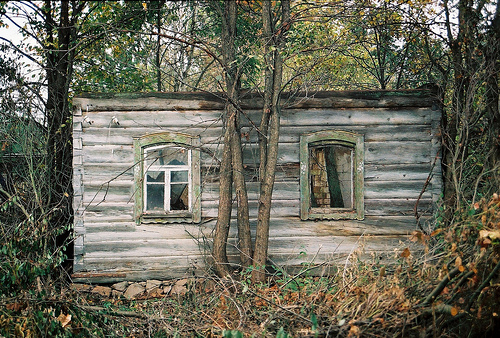<image>
Is the rocks next to the cabin? Yes. The rocks is positioned adjacent to the cabin, located nearby in the same general area. 